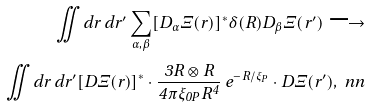Convert formula to latex. <formula><loc_0><loc_0><loc_500><loc_500>\iint d r \, d r ^ { \prime } \sum _ { \alpha , \beta } [ D _ { \alpha } \Xi ( r ) ] ^ { * } \delta ( R ) D _ { \beta } \Xi ( r ^ { \prime } ) \longrightarrow \\ \iint d r \, d r ^ { \prime } [ D \Xi ( r ) ] ^ { * } \cdot \frac { 3 R \otimes R } { 4 \pi \xi _ { 0 P } R ^ { 4 } } \, e ^ { - R / \xi _ { P } } \cdot D \Xi ( r ^ { \prime } ) , \ n n</formula> 